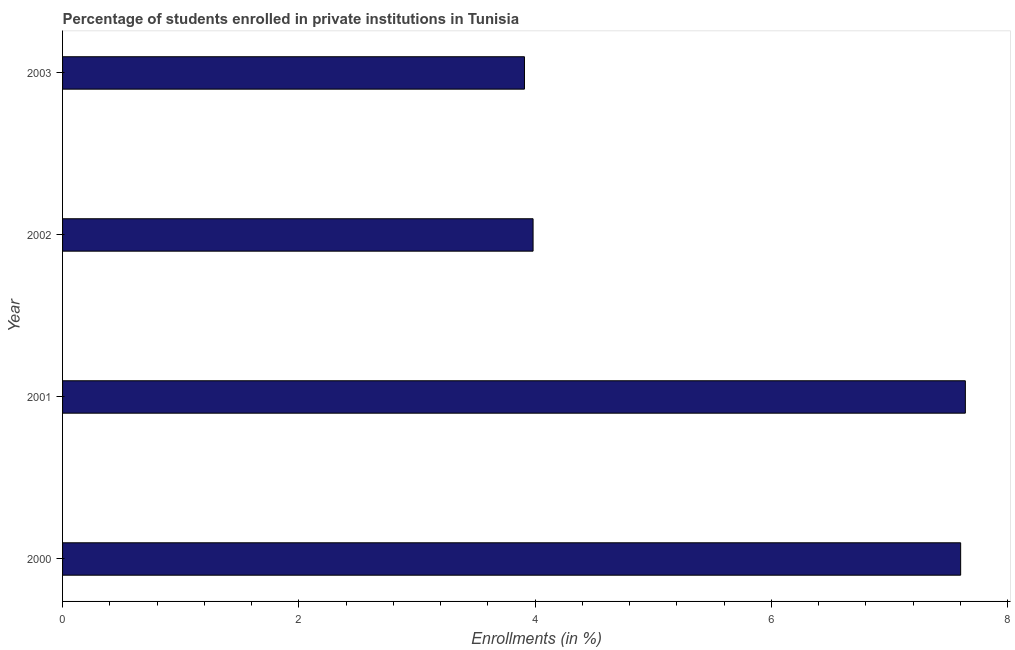Does the graph contain grids?
Your answer should be compact. No. What is the title of the graph?
Keep it short and to the point. Percentage of students enrolled in private institutions in Tunisia. What is the label or title of the X-axis?
Your response must be concise. Enrollments (in %). What is the label or title of the Y-axis?
Give a very brief answer. Year. What is the enrollments in private institutions in 2000?
Offer a very short reply. 7.6. Across all years, what is the maximum enrollments in private institutions?
Your answer should be compact. 7.64. Across all years, what is the minimum enrollments in private institutions?
Offer a terse response. 3.91. In which year was the enrollments in private institutions minimum?
Provide a short and direct response. 2003. What is the sum of the enrollments in private institutions?
Give a very brief answer. 23.14. What is the difference between the enrollments in private institutions in 2001 and 2003?
Give a very brief answer. 3.73. What is the average enrollments in private institutions per year?
Give a very brief answer. 5.79. What is the median enrollments in private institutions?
Your response must be concise. 5.79. In how many years, is the enrollments in private institutions greater than 5.2 %?
Offer a terse response. 2. What is the ratio of the enrollments in private institutions in 2000 to that in 2002?
Your answer should be compact. 1.91. Is the difference between the enrollments in private institutions in 2001 and 2002 greater than the difference between any two years?
Ensure brevity in your answer.  No. Is the sum of the enrollments in private institutions in 2001 and 2002 greater than the maximum enrollments in private institutions across all years?
Your answer should be compact. Yes. What is the difference between the highest and the lowest enrollments in private institutions?
Provide a short and direct response. 3.73. How many bars are there?
Give a very brief answer. 4. Are all the bars in the graph horizontal?
Keep it short and to the point. Yes. How many years are there in the graph?
Provide a short and direct response. 4. Are the values on the major ticks of X-axis written in scientific E-notation?
Provide a short and direct response. No. What is the Enrollments (in %) in 2000?
Give a very brief answer. 7.6. What is the Enrollments (in %) of 2001?
Give a very brief answer. 7.64. What is the Enrollments (in %) of 2002?
Your answer should be compact. 3.98. What is the Enrollments (in %) of 2003?
Offer a very short reply. 3.91. What is the difference between the Enrollments (in %) in 2000 and 2001?
Provide a short and direct response. -0.04. What is the difference between the Enrollments (in %) in 2000 and 2002?
Provide a short and direct response. 3.62. What is the difference between the Enrollments (in %) in 2000 and 2003?
Give a very brief answer. 3.69. What is the difference between the Enrollments (in %) in 2001 and 2002?
Make the answer very short. 3.66. What is the difference between the Enrollments (in %) in 2001 and 2003?
Your answer should be compact. 3.73. What is the difference between the Enrollments (in %) in 2002 and 2003?
Make the answer very short. 0.07. What is the ratio of the Enrollments (in %) in 2000 to that in 2002?
Make the answer very short. 1.91. What is the ratio of the Enrollments (in %) in 2000 to that in 2003?
Make the answer very short. 1.94. What is the ratio of the Enrollments (in %) in 2001 to that in 2002?
Offer a terse response. 1.92. What is the ratio of the Enrollments (in %) in 2001 to that in 2003?
Your answer should be compact. 1.95. What is the ratio of the Enrollments (in %) in 2002 to that in 2003?
Make the answer very short. 1.02. 